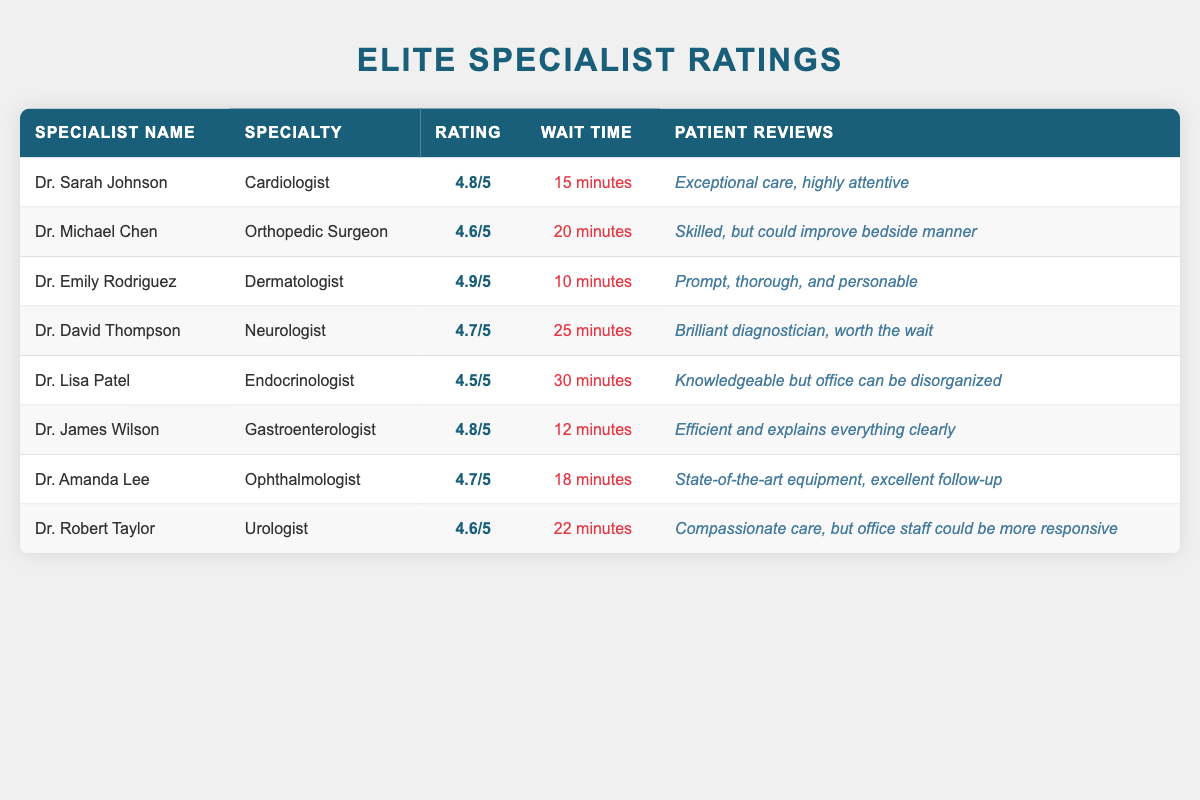What is the highest rating among the specialists? Looking at the "Rating" column, we can see that Dr. Emily Rodriguez has the highest rating at 4.9 out of 5.
Answer: 4.9/5 Which specialist has the shortest wait time? The "Wait Time" column shows that Dr. James Wilson has the shortest wait time of 12 minutes.
Answer: 12 minutes Is Dr. Lisa Patel rated higher than Dr. Michael Chen? Dr. Lisa Patel has a rating of 4.5/5 and Dr. Michael Chen has a rating of 4.6/5. Since 4.5 is less than 4.6, the answer is no.
Answer: No What is the average rating of all specialists? We sum the ratings: (4.8 + 4.6 + 4.9 + 4.7 + 4.5 + 4.8 + 4.7 + 4.6) = 37.6. There are 8 specialists, so the average rating is 37.6 / 8 = 4.7.
Answer: 4.7 Do Dr. Robert Taylor and Dr. Amanda Lee have the same rating? Dr. Robert Taylor's rating is 4.6/5 and Dr. Amanda Lee's rating is 4.7/5. Since these ratings are different, the answer is no.
Answer: No 